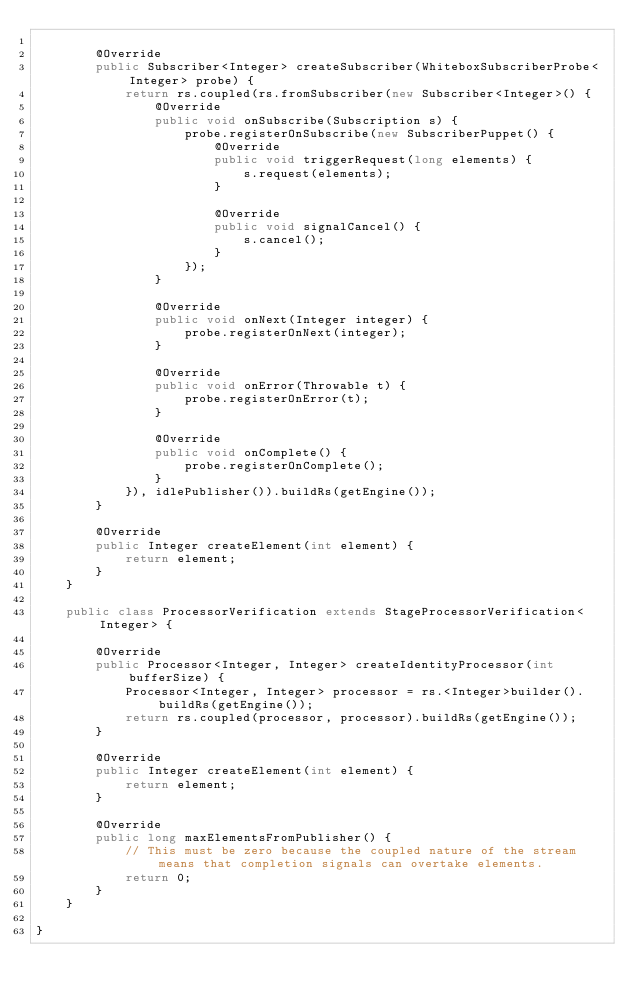<code> <loc_0><loc_0><loc_500><loc_500><_Java_>
        @Override
        public Subscriber<Integer> createSubscriber(WhiteboxSubscriberProbe<Integer> probe) {
            return rs.coupled(rs.fromSubscriber(new Subscriber<Integer>() {
                @Override
                public void onSubscribe(Subscription s) {
                    probe.registerOnSubscribe(new SubscriberPuppet() {
                        @Override
                        public void triggerRequest(long elements) {
                            s.request(elements);
                        }

                        @Override
                        public void signalCancel() {
                            s.cancel();
                        }
                    });
                }

                @Override
                public void onNext(Integer integer) {
                    probe.registerOnNext(integer);
                }

                @Override
                public void onError(Throwable t) {
                    probe.registerOnError(t);
                }

                @Override
                public void onComplete() {
                    probe.registerOnComplete();
                }
            }), idlePublisher()).buildRs(getEngine());
        }

        @Override
        public Integer createElement(int element) {
            return element;
        }
    }

    public class ProcessorVerification extends StageProcessorVerification<Integer> {

        @Override
        public Processor<Integer, Integer> createIdentityProcessor(int bufferSize) {
            Processor<Integer, Integer> processor = rs.<Integer>builder().buildRs(getEngine());
            return rs.coupled(processor, processor).buildRs(getEngine());
        }

        @Override
        public Integer createElement(int element) {
            return element;
        }

        @Override
        public long maxElementsFromPublisher() {
            // This must be zero because the coupled nature of the stream means that completion signals can overtake elements.
            return 0;
        }
    }

}
</code> 